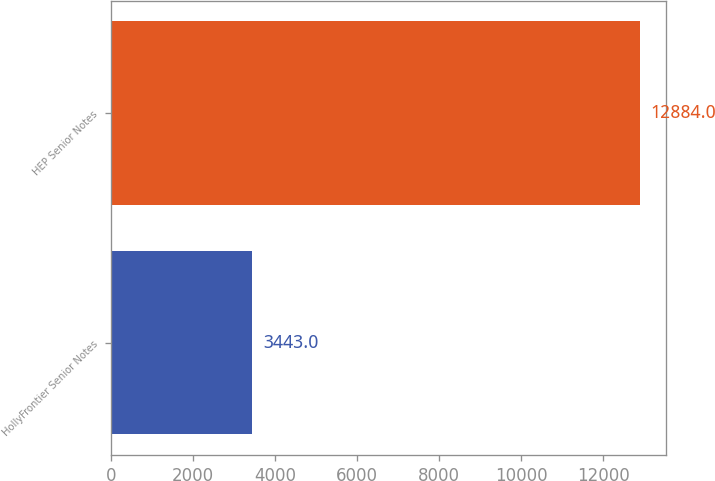Convert chart. <chart><loc_0><loc_0><loc_500><loc_500><bar_chart><fcel>HollyFrontier Senior Notes<fcel>HEP Senior Notes<nl><fcel>3443<fcel>12884<nl></chart> 